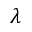Convert formula to latex. <formula><loc_0><loc_0><loc_500><loc_500>\lambda</formula> 